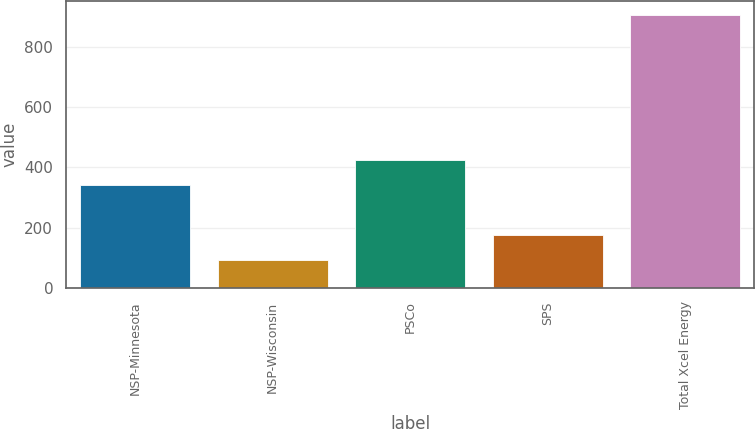Convert chart to OTSL. <chart><loc_0><loc_0><loc_500><loc_500><bar_chart><fcel>NSP-Minnesota<fcel>NSP-Wisconsin<fcel>PSCo<fcel>SPS<fcel>Total Xcel Energy<nl><fcel>342<fcel>94<fcel>423.2<fcel>175.2<fcel>906<nl></chart> 